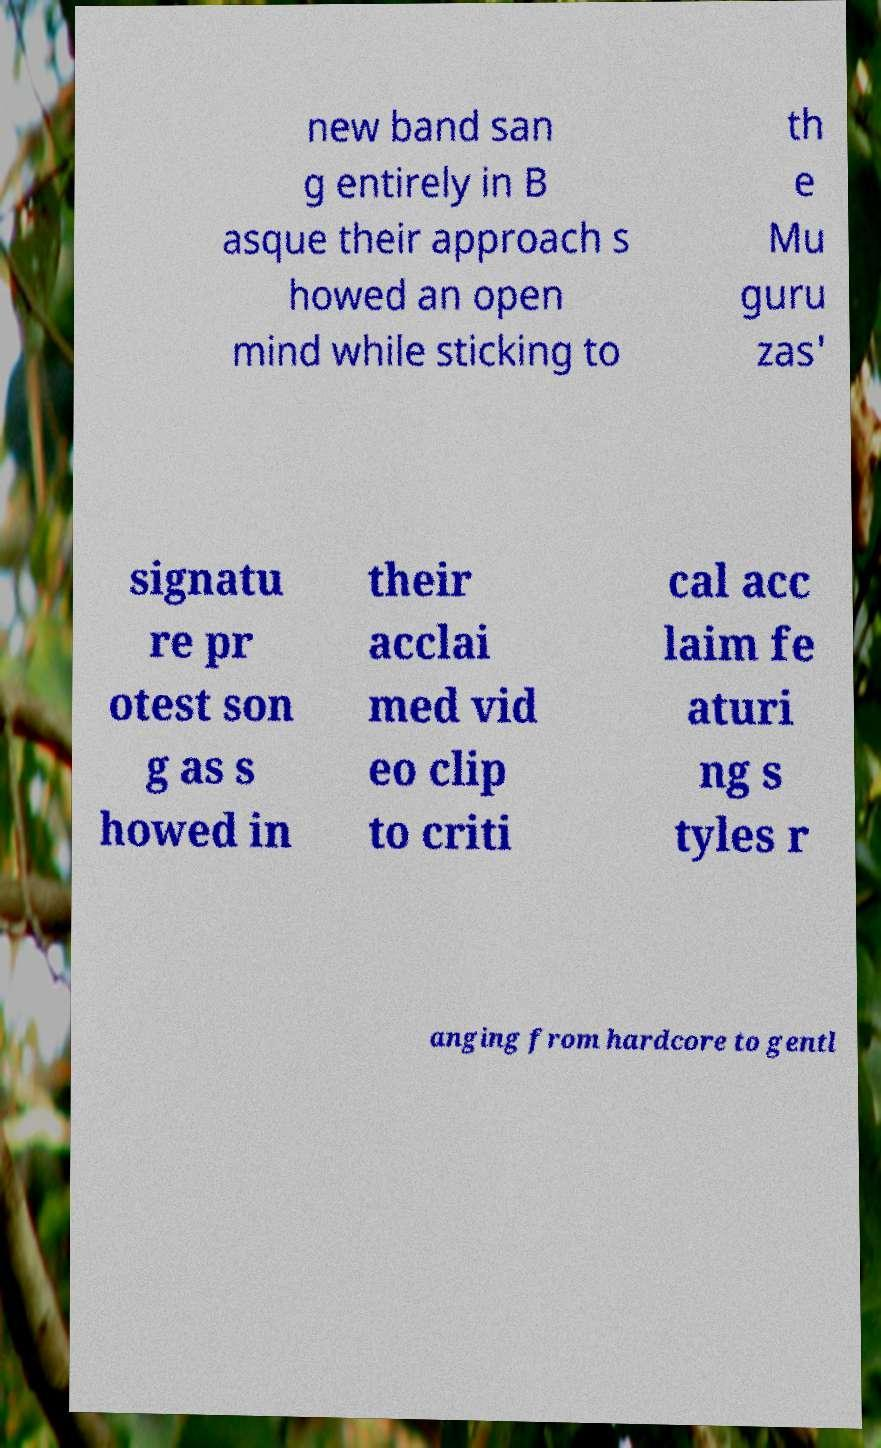What messages or text are displayed in this image? I need them in a readable, typed format. new band san g entirely in B asque their approach s howed an open mind while sticking to th e Mu guru zas' signatu re pr otest son g as s howed in their acclai med vid eo clip to criti cal acc laim fe aturi ng s tyles r anging from hardcore to gentl 